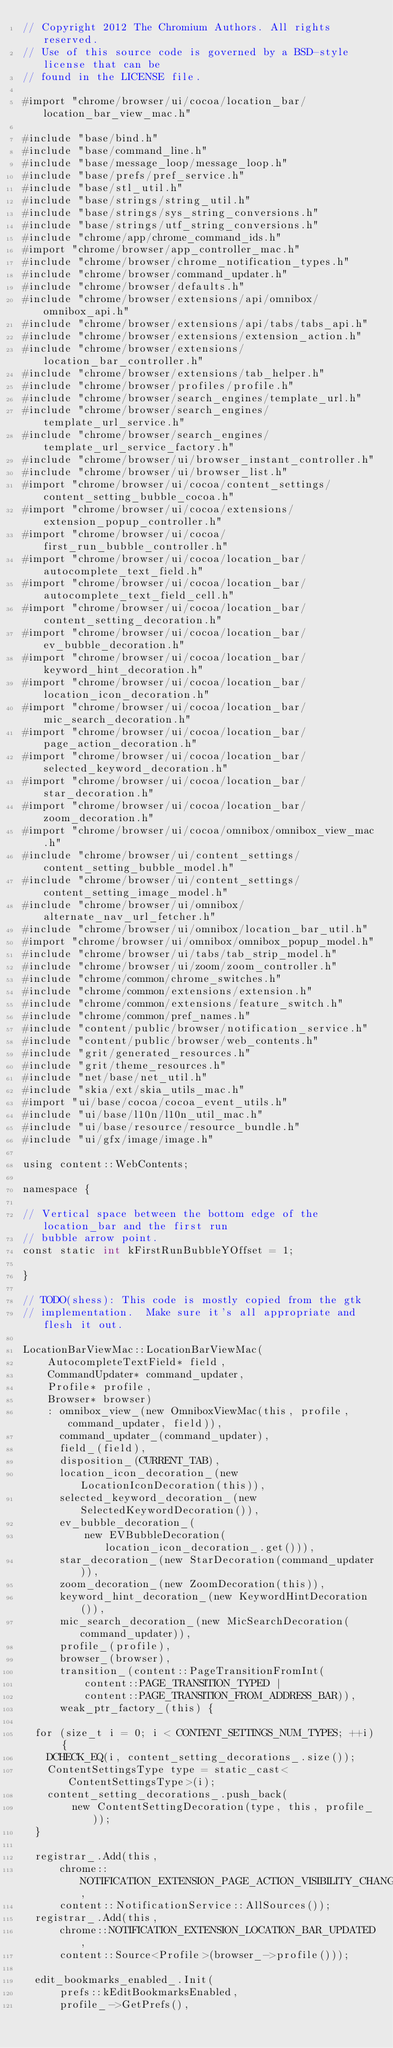Convert code to text. <code><loc_0><loc_0><loc_500><loc_500><_ObjectiveC_>// Copyright 2012 The Chromium Authors. All rights reserved.
// Use of this source code is governed by a BSD-style license that can be
// found in the LICENSE file.

#import "chrome/browser/ui/cocoa/location_bar/location_bar_view_mac.h"

#include "base/bind.h"
#include "base/command_line.h"
#include "base/message_loop/message_loop.h"
#include "base/prefs/pref_service.h"
#include "base/stl_util.h"
#include "base/strings/string_util.h"
#include "base/strings/sys_string_conversions.h"
#include "base/strings/utf_string_conversions.h"
#include "chrome/app/chrome_command_ids.h"
#import "chrome/browser/app_controller_mac.h"
#include "chrome/browser/chrome_notification_types.h"
#include "chrome/browser/command_updater.h"
#include "chrome/browser/defaults.h"
#include "chrome/browser/extensions/api/omnibox/omnibox_api.h"
#include "chrome/browser/extensions/api/tabs/tabs_api.h"
#include "chrome/browser/extensions/extension_action.h"
#include "chrome/browser/extensions/location_bar_controller.h"
#include "chrome/browser/extensions/tab_helper.h"
#include "chrome/browser/profiles/profile.h"
#include "chrome/browser/search_engines/template_url.h"
#include "chrome/browser/search_engines/template_url_service.h"
#include "chrome/browser/search_engines/template_url_service_factory.h"
#include "chrome/browser/ui/browser_instant_controller.h"
#include "chrome/browser/ui/browser_list.h"
#import "chrome/browser/ui/cocoa/content_settings/content_setting_bubble_cocoa.h"
#import "chrome/browser/ui/cocoa/extensions/extension_popup_controller.h"
#import "chrome/browser/ui/cocoa/first_run_bubble_controller.h"
#import "chrome/browser/ui/cocoa/location_bar/autocomplete_text_field.h"
#import "chrome/browser/ui/cocoa/location_bar/autocomplete_text_field_cell.h"
#import "chrome/browser/ui/cocoa/location_bar/content_setting_decoration.h"
#import "chrome/browser/ui/cocoa/location_bar/ev_bubble_decoration.h"
#import "chrome/browser/ui/cocoa/location_bar/keyword_hint_decoration.h"
#import "chrome/browser/ui/cocoa/location_bar/location_icon_decoration.h"
#import "chrome/browser/ui/cocoa/location_bar/mic_search_decoration.h"
#import "chrome/browser/ui/cocoa/location_bar/page_action_decoration.h"
#import "chrome/browser/ui/cocoa/location_bar/selected_keyword_decoration.h"
#import "chrome/browser/ui/cocoa/location_bar/star_decoration.h"
#import "chrome/browser/ui/cocoa/location_bar/zoom_decoration.h"
#import "chrome/browser/ui/cocoa/omnibox/omnibox_view_mac.h"
#include "chrome/browser/ui/content_settings/content_setting_bubble_model.h"
#include "chrome/browser/ui/content_settings/content_setting_image_model.h"
#include "chrome/browser/ui/omnibox/alternate_nav_url_fetcher.h"
#include "chrome/browser/ui/omnibox/location_bar_util.h"
#import "chrome/browser/ui/omnibox/omnibox_popup_model.h"
#include "chrome/browser/ui/tabs/tab_strip_model.h"
#include "chrome/browser/ui/zoom/zoom_controller.h"
#include "chrome/common/chrome_switches.h"
#include "chrome/common/extensions/extension.h"
#include "chrome/common/extensions/feature_switch.h"
#include "chrome/common/pref_names.h"
#include "content/public/browser/notification_service.h"
#include "content/public/browser/web_contents.h"
#include "grit/generated_resources.h"
#include "grit/theme_resources.h"
#include "net/base/net_util.h"
#include "skia/ext/skia_utils_mac.h"
#import "ui/base/cocoa/cocoa_event_utils.h"
#include "ui/base/l10n/l10n_util_mac.h"
#include "ui/base/resource/resource_bundle.h"
#include "ui/gfx/image/image.h"

using content::WebContents;

namespace {

// Vertical space between the bottom edge of the location_bar and the first run
// bubble arrow point.
const static int kFirstRunBubbleYOffset = 1;

}

// TODO(shess): This code is mostly copied from the gtk
// implementation.  Make sure it's all appropriate and flesh it out.

LocationBarViewMac::LocationBarViewMac(
    AutocompleteTextField* field,
    CommandUpdater* command_updater,
    Profile* profile,
    Browser* browser)
    : omnibox_view_(new OmniboxViewMac(this, profile, command_updater, field)),
      command_updater_(command_updater),
      field_(field),
      disposition_(CURRENT_TAB),
      location_icon_decoration_(new LocationIconDecoration(this)),
      selected_keyword_decoration_(new SelectedKeywordDecoration()),
      ev_bubble_decoration_(
          new EVBubbleDecoration(location_icon_decoration_.get())),
      star_decoration_(new StarDecoration(command_updater)),
      zoom_decoration_(new ZoomDecoration(this)),
      keyword_hint_decoration_(new KeywordHintDecoration()),
      mic_search_decoration_(new MicSearchDecoration(command_updater)),
      profile_(profile),
      browser_(browser),
      transition_(content::PageTransitionFromInt(
          content::PAGE_TRANSITION_TYPED |
          content::PAGE_TRANSITION_FROM_ADDRESS_BAR)),
      weak_ptr_factory_(this) {

  for (size_t i = 0; i < CONTENT_SETTINGS_NUM_TYPES; ++i) {
    DCHECK_EQ(i, content_setting_decorations_.size());
    ContentSettingsType type = static_cast<ContentSettingsType>(i);
    content_setting_decorations_.push_back(
        new ContentSettingDecoration(type, this, profile_));
  }

  registrar_.Add(this,
      chrome::NOTIFICATION_EXTENSION_PAGE_ACTION_VISIBILITY_CHANGED,
      content::NotificationService::AllSources());
  registrar_.Add(this,
      chrome::NOTIFICATION_EXTENSION_LOCATION_BAR_UPDATED,
      content::Source<Profile>(browser_->profile()));

  edit_bookmarks_enabled_.Init(
      prefs::kEditBookmarksEnabled,
      profile_->GetPrefs(),</code> 